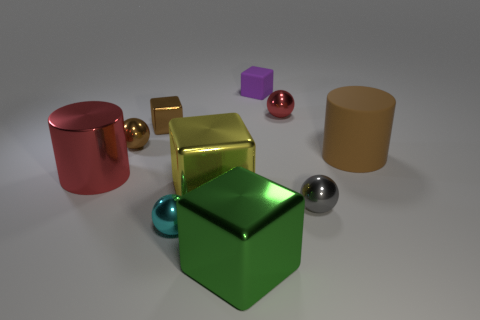How many tiny red spheres are made of the same material as the brown cylinder?
Offer a terse response. 0. What is the size of the red object that is the same shape as the tiny cyan metallic object?
Keep it short and to the point. Small. Do the green metallic object and the cyan metal object have the same size?
Your answer should be compact. No. What shape is the red metallic thing that is behind the big cylinder right of the red metallic object that is in front of the brown matte object?
Provide a short and direct response. Sphere. The other tiny object that is the same shape as the purple thing is what color?
Provide a short and direct response. Brown. How big is the metallic sphere that is both behind the metal cylinder and on the right side of the small brown cube?
Offer a terse response. Small. How many tiny purple blocks are to the left of the matte object behind the big brown rubber thing in front of the tiny rubber thing?
Your response must be concise. 0. How many small objects are green things or green rubber balls?
Provide a short and direct response. 0. Is the material of the cylinder in front of the large brown thing the same as the green thing?
Provide a succinct answer. Yes. The large cylinder that is on the right side of the shiny cube behind the cylinder on the right side of the gray metal ball is made of what material?
Ensure brevity in your answer.  Rubber. 